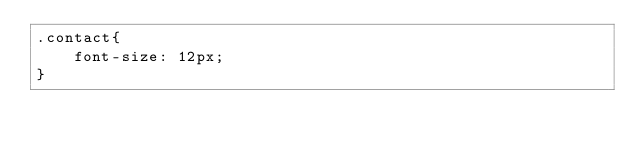<code> <loc_0><loc_0><loc_500><loc_500><_CSS_>.contact{
    font-size: 12px;
}</code> 